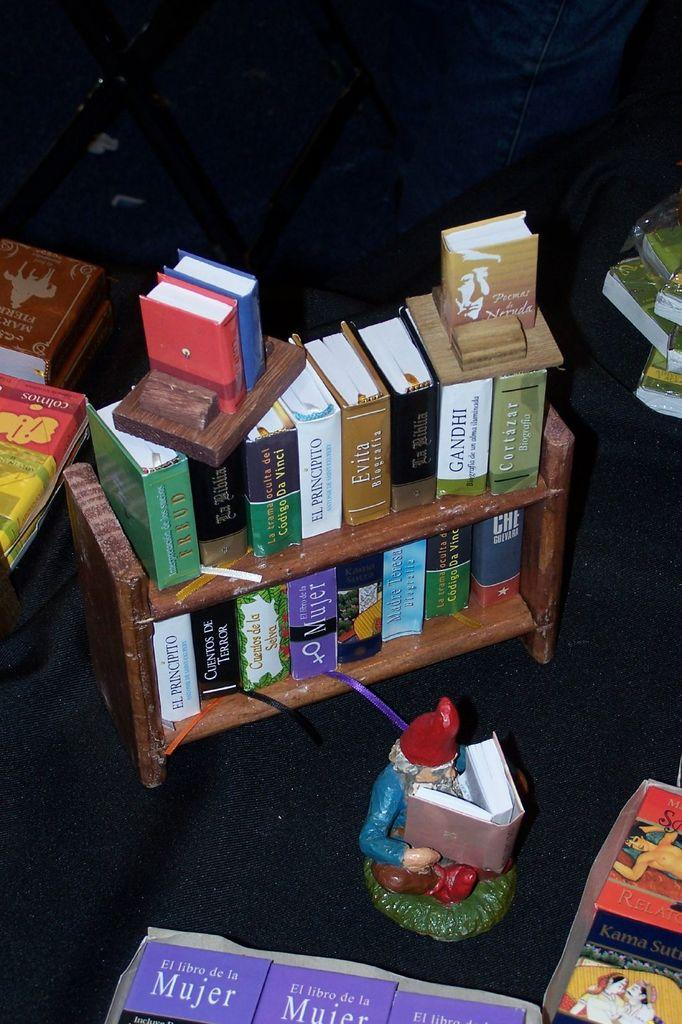<image>
Present a compact description of the photo's key features. A collection of books includes several copies of El Libro De La Mujer with a purple cover. 